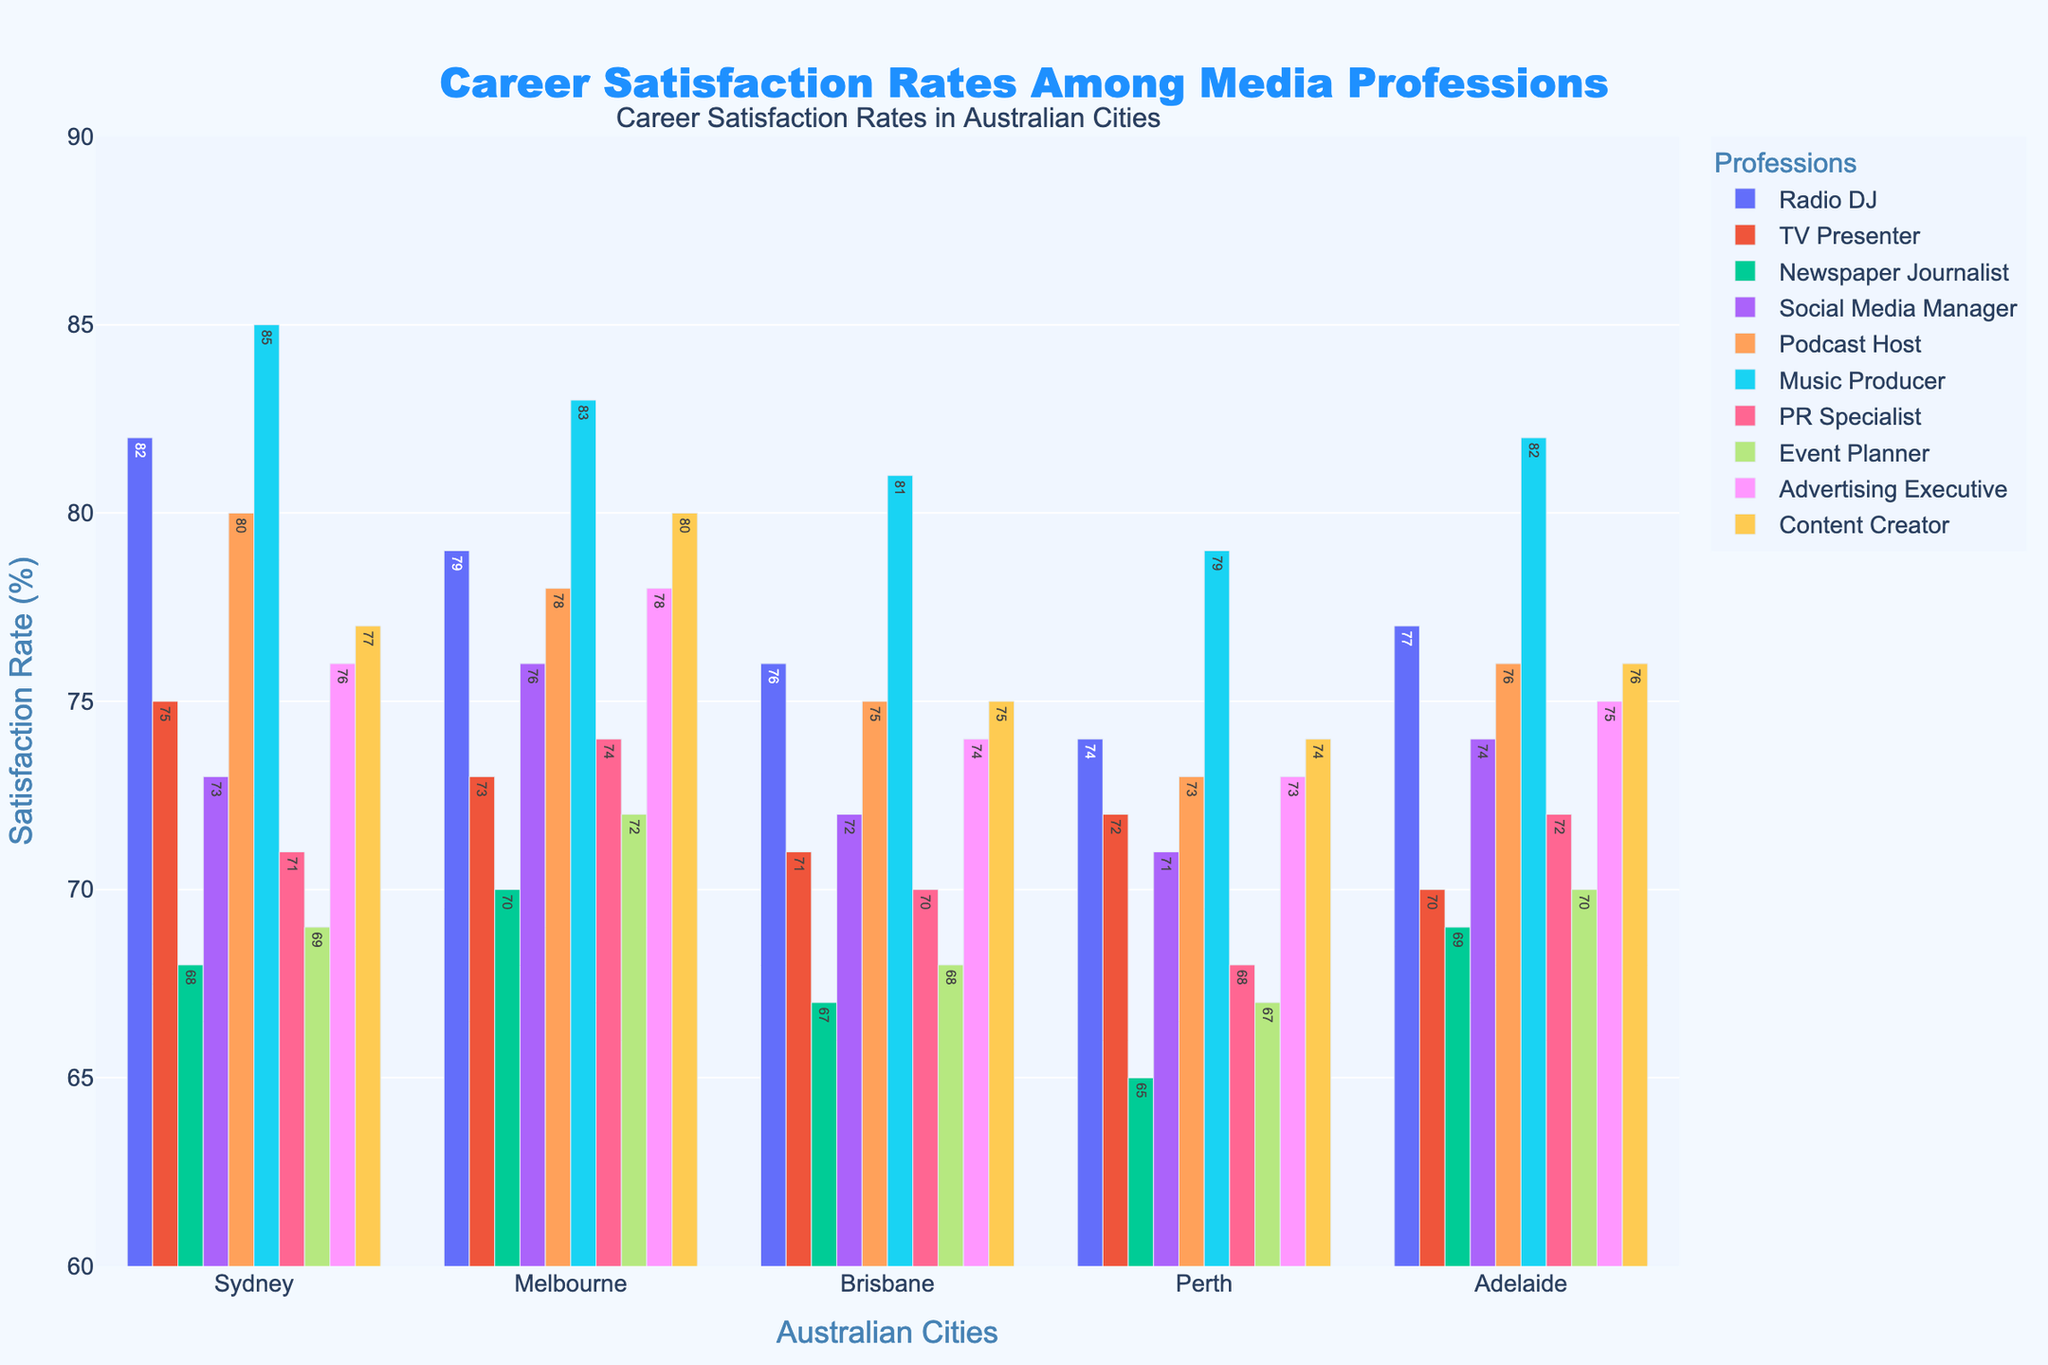What is the highest career satisfaction rate for Radio DJs in any city? Look at the bar for Radio DJs across all cities and identify the tallest bar. The tallest bar is for Sydney at 82%.
Answer: 82% Which profession has the lowest career satisfaction rate in Perth? Look at the bars for Perth and identify the shortest bar. The shortest bar for Perth is the Newspaper Journalist at 65%.
Answer: Newspaper Journalist How does the satisfaction rate of Music Producers in Brisbane compare to that of Radio DJs in the same city? Compare the bars for Music Producers and Radio DJs in Brisbane. Music Producers have a satisfaction rate of 81% while Radio DJs have 76%. So, Music Producers have a higher satisfaction rate.
Answer: Music Producers have a higher satisfaction rate Which profession has an equal or nearly equal satisfaction rate to Radio DJs in Melbourne? Look at the bar for Radio DJs in Melbourne (79%) and compare it with other professions in Melbourne. The closest is Content Creator with a satisfaction rate of 80%.
Answer: Content Creator What is the average career satisfaction rate of Podcast Hosts across all cities? Sum the satisfaction rates of Podcast Hosts in all cities (80 + 78 + 75 + 73 + 76) and divide by the number of cities (5). So, (80 + 78 + 75 + 73 + 76) / 5 = 76.4.
Answer: 76.4% Who has a higher satisfaction rate in Sydney: Social Media Managers or Advertising Executives? Compare the bars for Social Media Managers (73%) and Advertising Executives (76%) in Sydney. Advertising Executives have a higher satisfaction rate.
Answer: Advertising Executives Is the career satisfaction of TV Presenters in Adelaide more or less than that of Event Planners in Sydney? Compare the satisfaction rate of TV Presenters in Adelaide (70%) to that of Event Planners in Sydney (69%). TV Presenters in Adelaide have a higher satisfaction rate.
Answer: More What is the difference in satisfaction rates between PR Specialists in Brisbane and Social Media Managers in Perth? Find the satisfaction rates of PR Specialists in Brisbane (70%) and Social Media Managers in Perth (71%) and calculate the difference. 71% - 70% = 1%.
Answer: 1% Which two professions have the most similar satisfaction rates in Adelaide? Compare the heights of all bars in Adelaide and find the two closest ones. Radio DJs and Social Media Managers both have satisfaction rates of 77%.
Answer: Radio DJs and Social Media Managers In which city do Music Producers have the highest satisfaction rate? Look at the bars for Music Producers and identify the tallest one. The tallest bar is in Sydney at 85%.
Answer: Sydney 